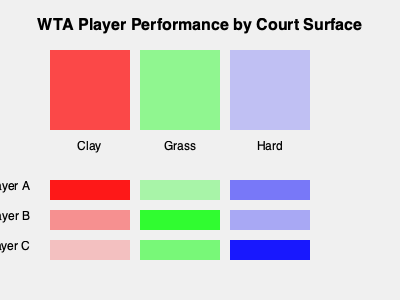Based on the heat map, which player shows the highest performance on grass courts, and how does this compare to their performance on other surfaces? To answer this question, we need to analyze the heat map for each player across different court surfaces:

1. Interpret the heat map:
   - Darker colors indicate better performance
   - Each row represents a player (A, B, C)
   - Each column represents a court surface (Clay, Grass, Hard)

2. Analyze Player A:
   - Strong on clay (dark red)
   - Weak on grass (light green)
   - Moderate on hard courts (medium blue)

3. Analyze Player B:
   - Moderate on clay (medium red)
   - Strong on grass (dark green)
   - Weak on hard courts (light blue)

4. Analyze Player C:
   - Weak on clay (light red)
   - Moderate on grass (medium green)
   - Strong on hard courts (dark blue)

5. Compare grass court performance:
   - Player A: Light green (weak)
   - Player B: Dark green (strong)
   - Player C: Medium green (moderate)

6. Conclusion:
   - Player B shows the highest performance on grass courts
   - This is significantly better than their performance on other surfaces, especially hard courts where they show the weakest performance
Answer: Player B; significantly better than on other surfaces 